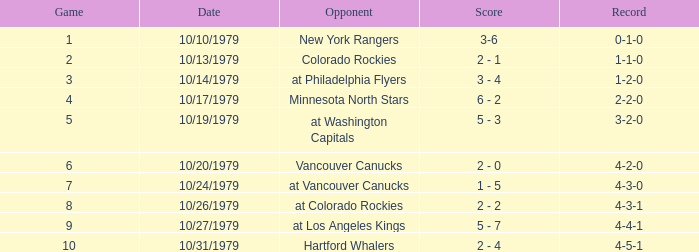How many points has the team playing against the vancouver canucks earned? 2 - 0. 